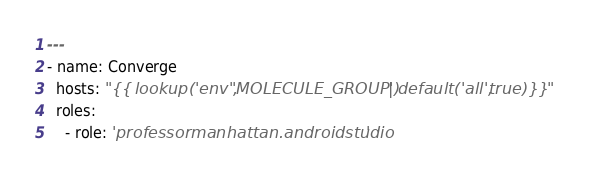Convert code to text. <code><loc_0><loc_0><loc_500><loc_500><_YAML_>---
- name: Converge
  hosts: "{{ lookup('env', 'MOLECULE_GROUP') | default('all', true) }}"
  roles:
    - role: 'professormanhattan.androidstudio'
</code> 